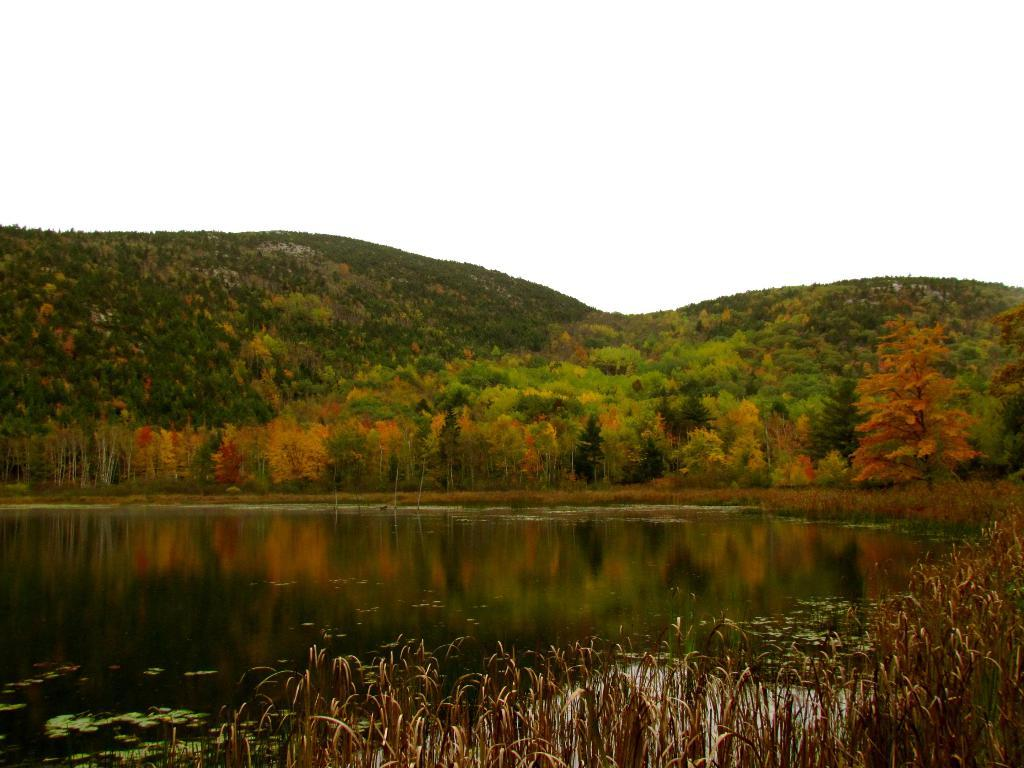What type of vegetation can be seen in the image? There are trees in the image. What geographical features are present in the image? There are hills in the image. What is visible at the bottom of the image? There is water and plants visible at the bottom of the image. What part of the natural environment is visible at the top of the image? The sky is visible at the top of the image. Can you describe the impulse of the water in the image? There is no impulse or movement of the water in the image; it is stationary. What type of exchange is happening between the trees and the plants in the image? There is no exchange between the trees and the plants in the image; they are separate entities. 